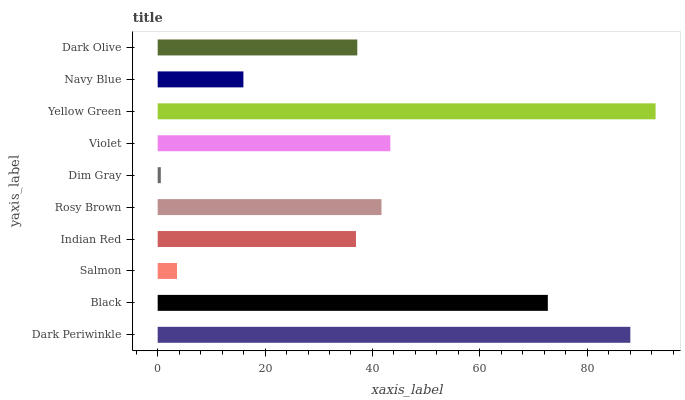Is Dim Gray the minimum?
Answer yes or no. Yes. Is Yellow Green the maximum?
Answer yes or no. Yes. Is Black the minimum?
Answer yes or no. No. Is Black the maximum?
Answer yes or no. No. Is Dark Periwinkle greater than Black?
Answer yes or no. Yes. Is Black less than Dark Periwinkle?
Answer yes or no. Yes. Is Black greater than Dark Periwinkle?
Answer yes or no. No. Is Dark Periwinkle less than Black?
Answer yes or no. No. Is Rosy Brown the high median?
Answer yes or no. Yes. Is Dark Olive the low median?
Answer yes or no. Yes. Is Salmon the high median?
Answer yes or no. No. Is Salmon the low median?
Answer yes or no. No. 